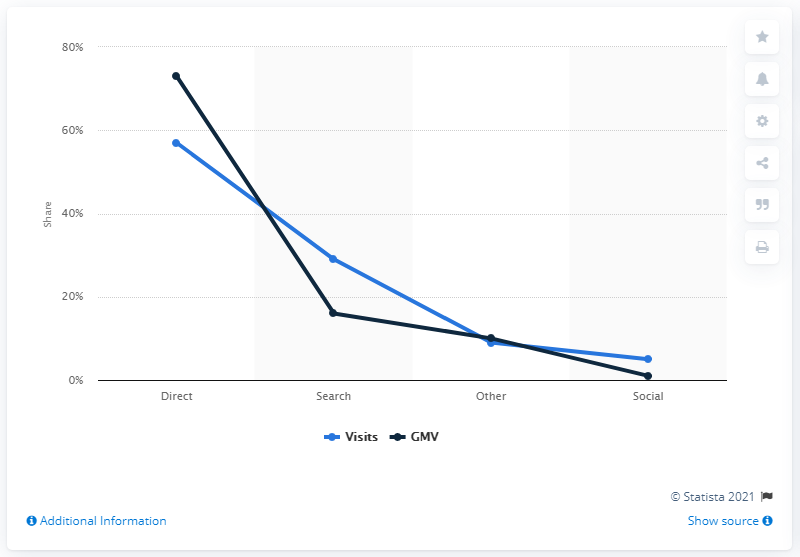Give some essential details in this illustration. In the first half of 2018, direct traffic accounted for approximately 57% of all visits. Approximately 73% of e-retail GMV (gross merchandise volume) was generated from direct traffic in the given period. 